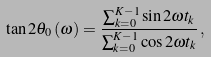<formula> <loc_0><loc_0><loc_500><loc_500>\tan 2 \theta _ { 0 } \left ( \omega \right ) = \frac { \sum _ { k = 0 } ^ { K - 1 } \sin 2 \omega t _ { k } } { \sum _ { k = 0 } ^ { K - 1 } \cos 2 \omega t _ { k } } \, ,</formula> 